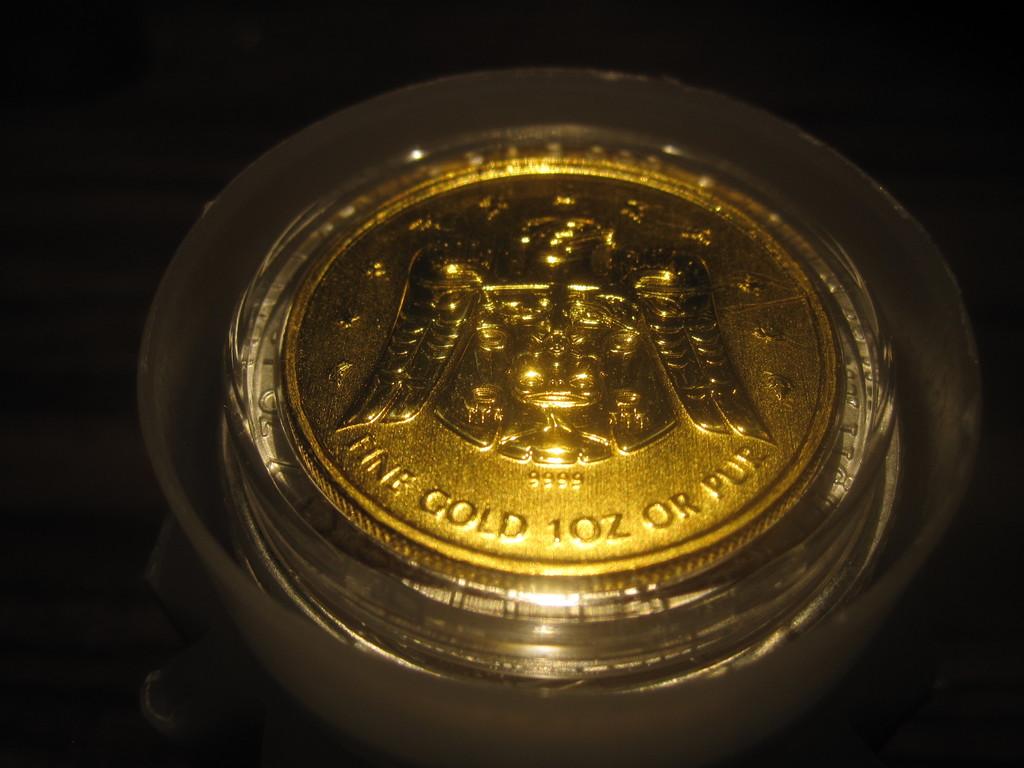How much does this coin weigh?
Make the answer very short. 1 oz. 